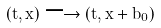Convert formula to latex. <formula><loc_0><loc_0><loc_500><loc_500>( t , x ) \longrightarrow ( t , x + b _ { 0 } )</formula> 